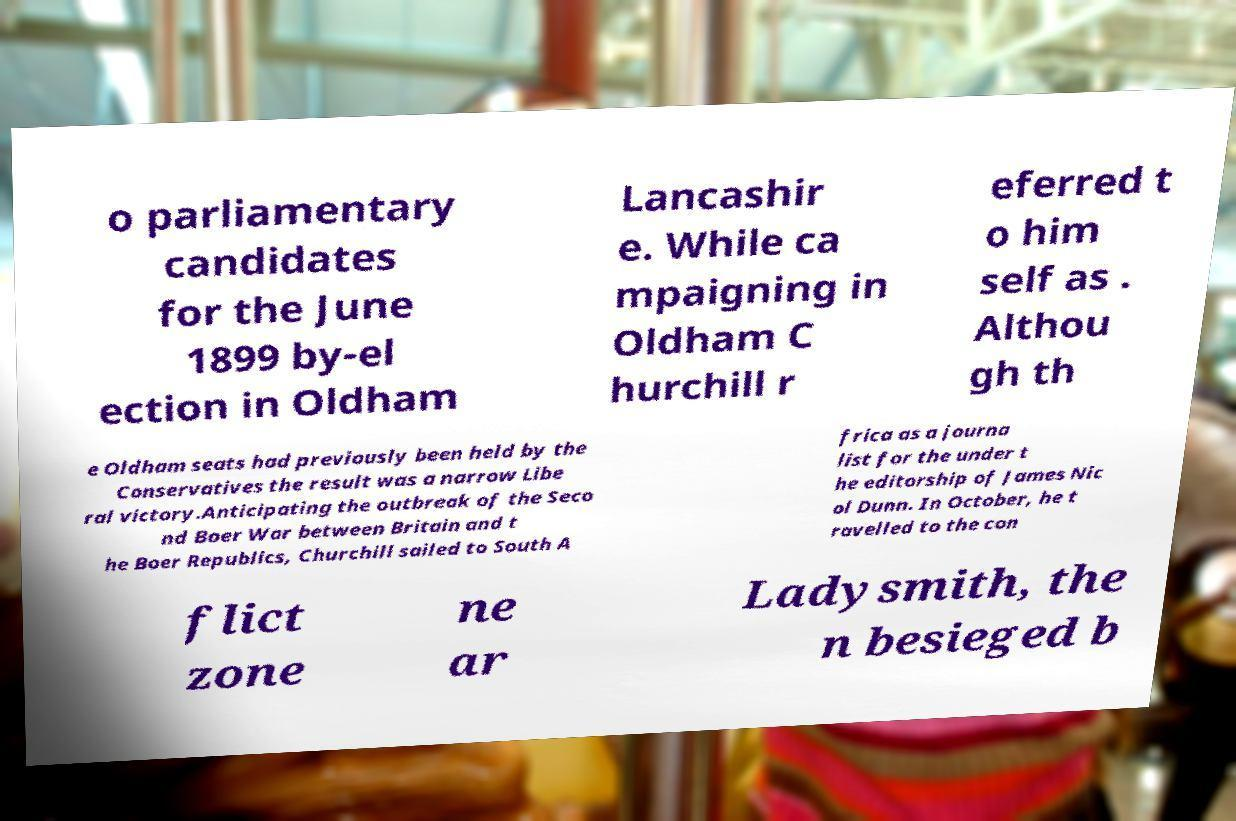There's text embedded in this image that I need extracted. Can you transcribe it verbatim? o parliamentary candidates for the June 1899 by-el ection in Oldham Lancashir e. While ca mpaigning in Oldham C hurchill r eferred t o him self as . Althou gh th e Oldham seats had previously been held by the Conservatives the result was a narrow Libe ral victory.Anticipating the outbreak of the Seco nd Boer War between Britain and t he Boer Republics, Churchill sailed to South A frica as a journa list for the under t he editorship of James Nic ol Dunn. In October, he t ravelled to the con flict zone ne ar Ladysmith, the n besieged b 